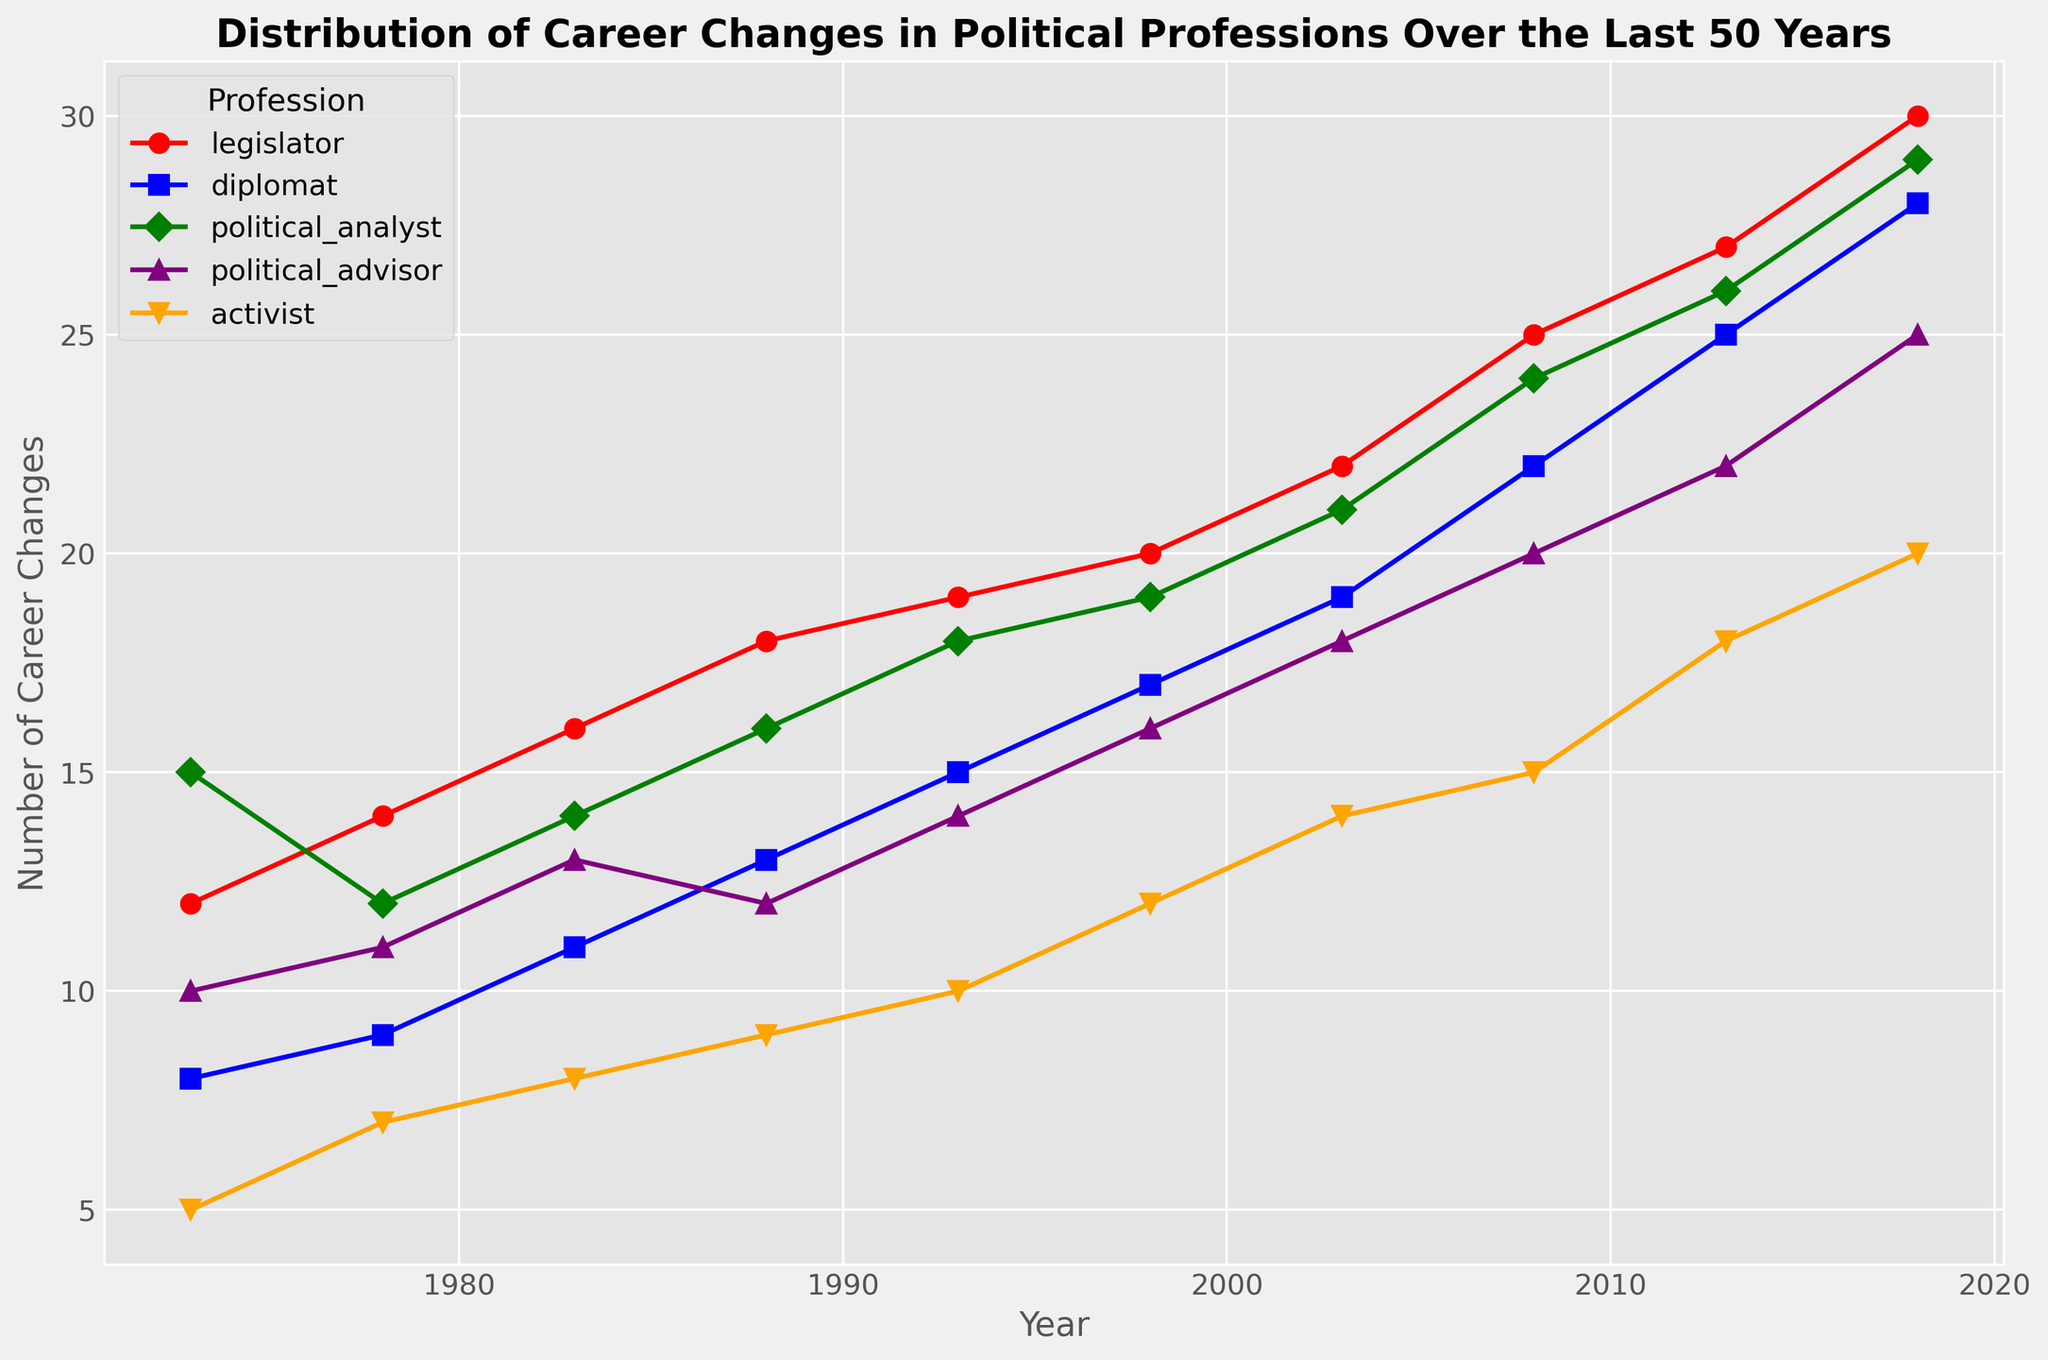What's the trend of career changes for the profession of legislators over the 50 years? To identify the trend for legislators, observe their plot line from 1973 to 2018. There is a consistent increase: 12 in 1973, gradually rising and reaching 30 by 2018.
Answer: Increasing Which profession had the least number of career changes in 1973? Compare the values for all professions in 1973. Legislator: 12, diplomat: 8, political analyst: 15, political advisor: 10, activist: 5. Activist had the smallest number.
Answer: Activist How does the number of career changes for political analysts in 2018 compare to that in 1993? Look at the data points for political analysts in 2018 and 1993. In 1993, it was 18, and in 2018, it was 29. There is an increase of 11 career changes.
Answer: Increased by 11 In which year did diplomats see the highest number of career changes? Observe the values for diplomats across the years. The highest value is 28 in 2018.
Answer: 2018 What's the difference in the number of career changes between political analysts and political advisors in 2008? Identify the values for 2008: political analysts: 24 and political advisors: 20. The difference is 24 - 20 = 4.
Answer: 4 Between 1978 and 1983, which profession saw the greatest increase in the number of career changes? Calculate the increase for each profession between these years: Legislator: 16 - 14 = 2, Diplomat: 11 - 9 = 2, Political analyst: 14 - 12 = 2, Political advisor: 13 - 11 = 2, Activist: 8 - 7=1. The increase for all is mostly 2.
Answer: All except activist What is the average number of career changes for activists across all years? Add the values for all years: 5 + 7 + 8 + 9 + 10 + 12 + 14 + 15 + 18 + 20 = 118. There are 10 years, so 118/10 = 11.8
Answer: 11.8 Compare the overall trend of career changes for diplomats with that of political advisors. Both plots show an upward trend, however, diplomats' career changes increase more gradually compared to political advisors.
Answer: Both increasing; diplomats less steep Which year had the highest increase in career changes for political advisors compared to the previous period? Calculate differences: 
1978 - 1973: 11-10 = 1, 
1983 - 1978: 13-11 = 2,  
1988 - 1983: 12-13= -1,
1993 - 1988: 14-12=2, 
1998 - 1993: 16-14=2,
2003 - 1998: 18-16=2, 
2008 - 2003: 20-18=2, 
2013 - 2008: 22-20=2, 
2018 - 2013: 25-22=3. Highest increase is between 2013 and 2018
Answer: 2013-2018 What can be inferred about career changes in political professions over the last 50 years? Looking at the trends of all professions, it's evident that there has been a general increase in career changes over time in all political professions.
Answer: Increasing trend 